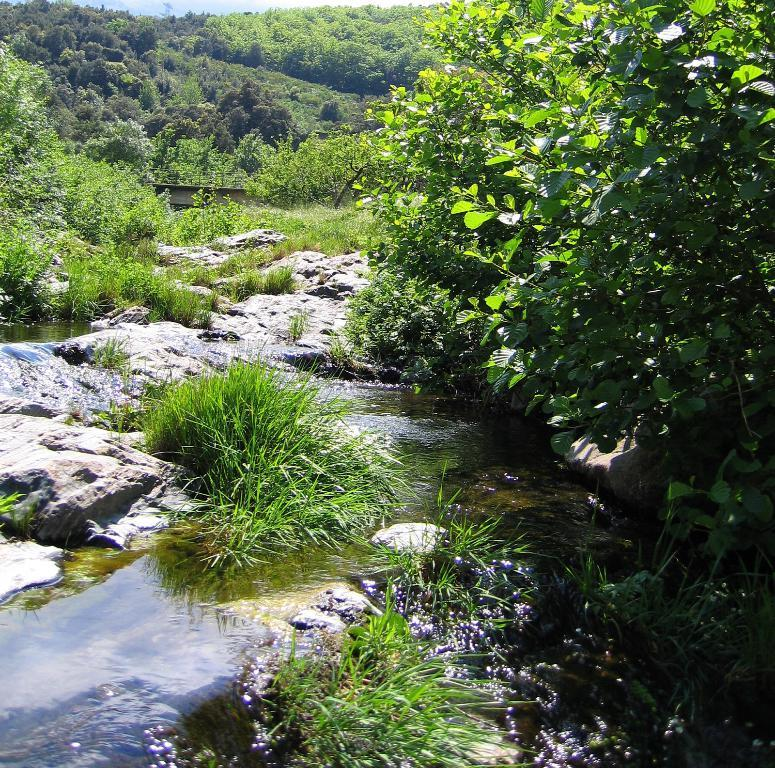What is the primary element present in the image? There is water in the image. What other objects or features can be seen in the image? There are rocks, plants, and trees in the image. What type of fuel is being used by the plant in the image? There is no plant or fuel present in the image; it features water, rocks, plants, and trees. 